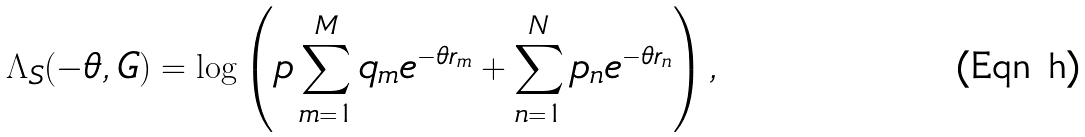Convert formula to latex. <formula><loc_0><loc_0><loc_500><loc_500>\Lambda _ { S } ( - \theta , G ) = \log \left ( p \sum _ { m = 1 } ^ { M } q _ { m } e ^ { - \theta r _ { m } } + \sum _ { n = 1 } ^ { N } p _ { n } e ^ { - \theta r _ { n } } \right ) ,</formula> 